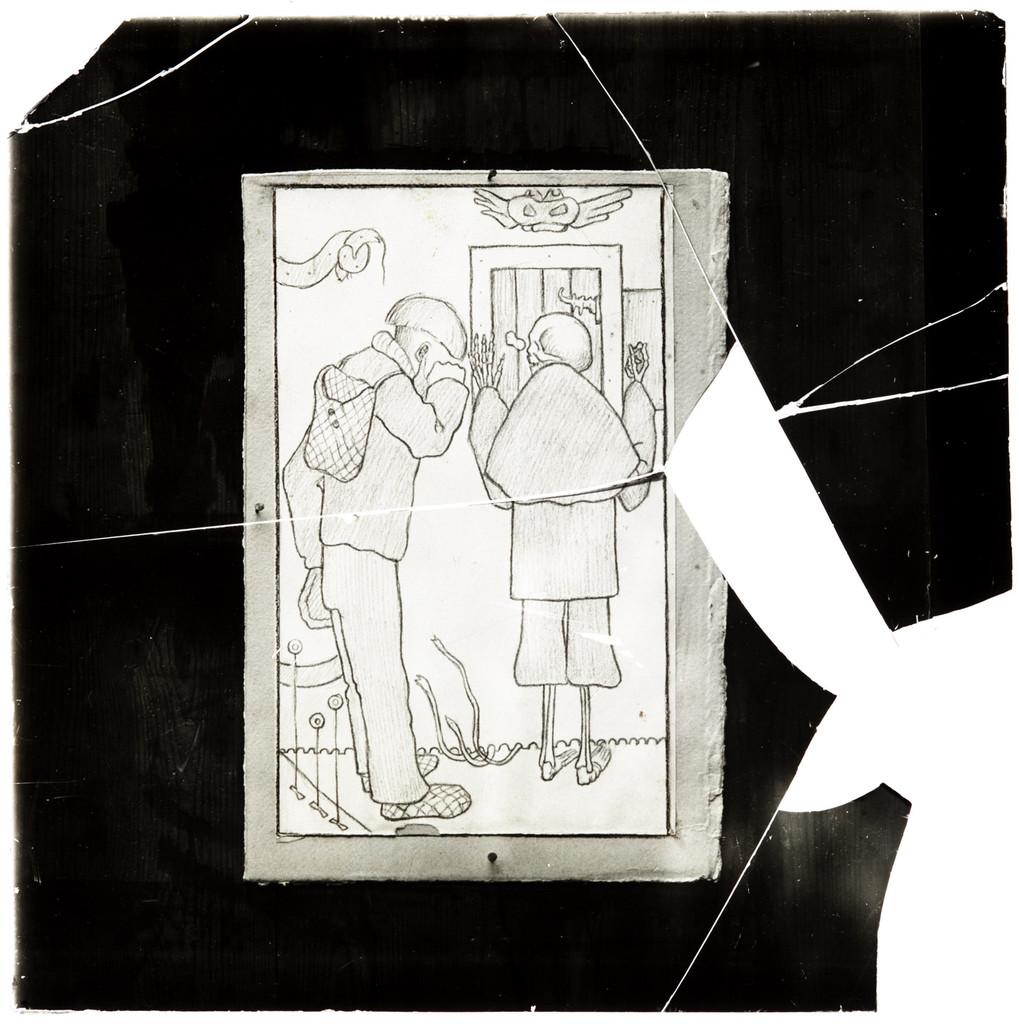What object is the main focus of the image? There is a photo frame in the image. What is depicted inside the photo frame? The photo frame contains a drawing of persons. How would you describe the color scheme of the drawing inside the photo frame? The background of the drawing inside the photo frame is black and white in color. Can you see any mountains or cacti in the image? No, there are no mountains or cacti present in the image. The image only features a photo frame with a drawing of persons inside. 